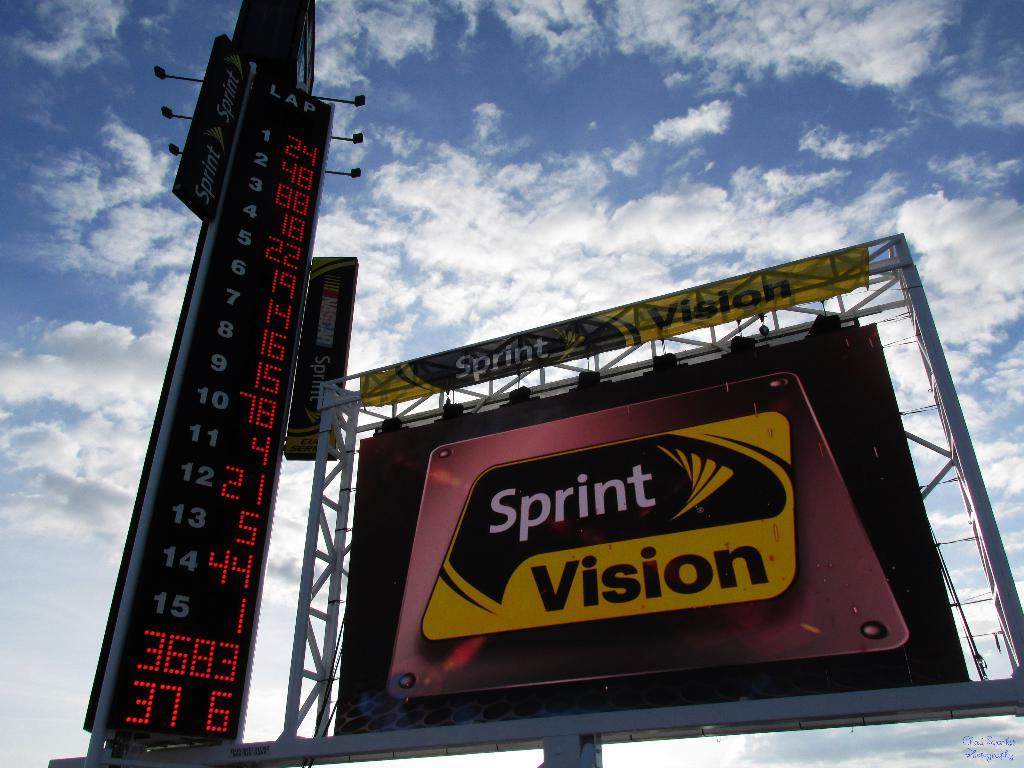<image>
Create a compact narrative representing the image presented. a sign outside that says Sprint Vision on it 